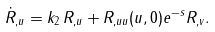<formula> <loc_0><loc_0><loc_500><loc_500>\dot { R } _ { , u } = k _ { 2 } \, R _ { , u } + R _ { , u u } ( u , 0 ) e ^ { - s } R _ { , v } .</formula> 